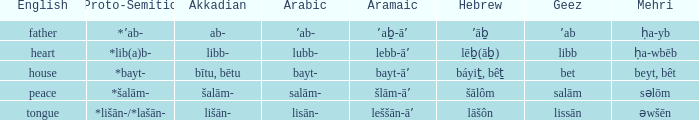What is the proto-semitic word for 'house' as it is in english? *bayt-. 